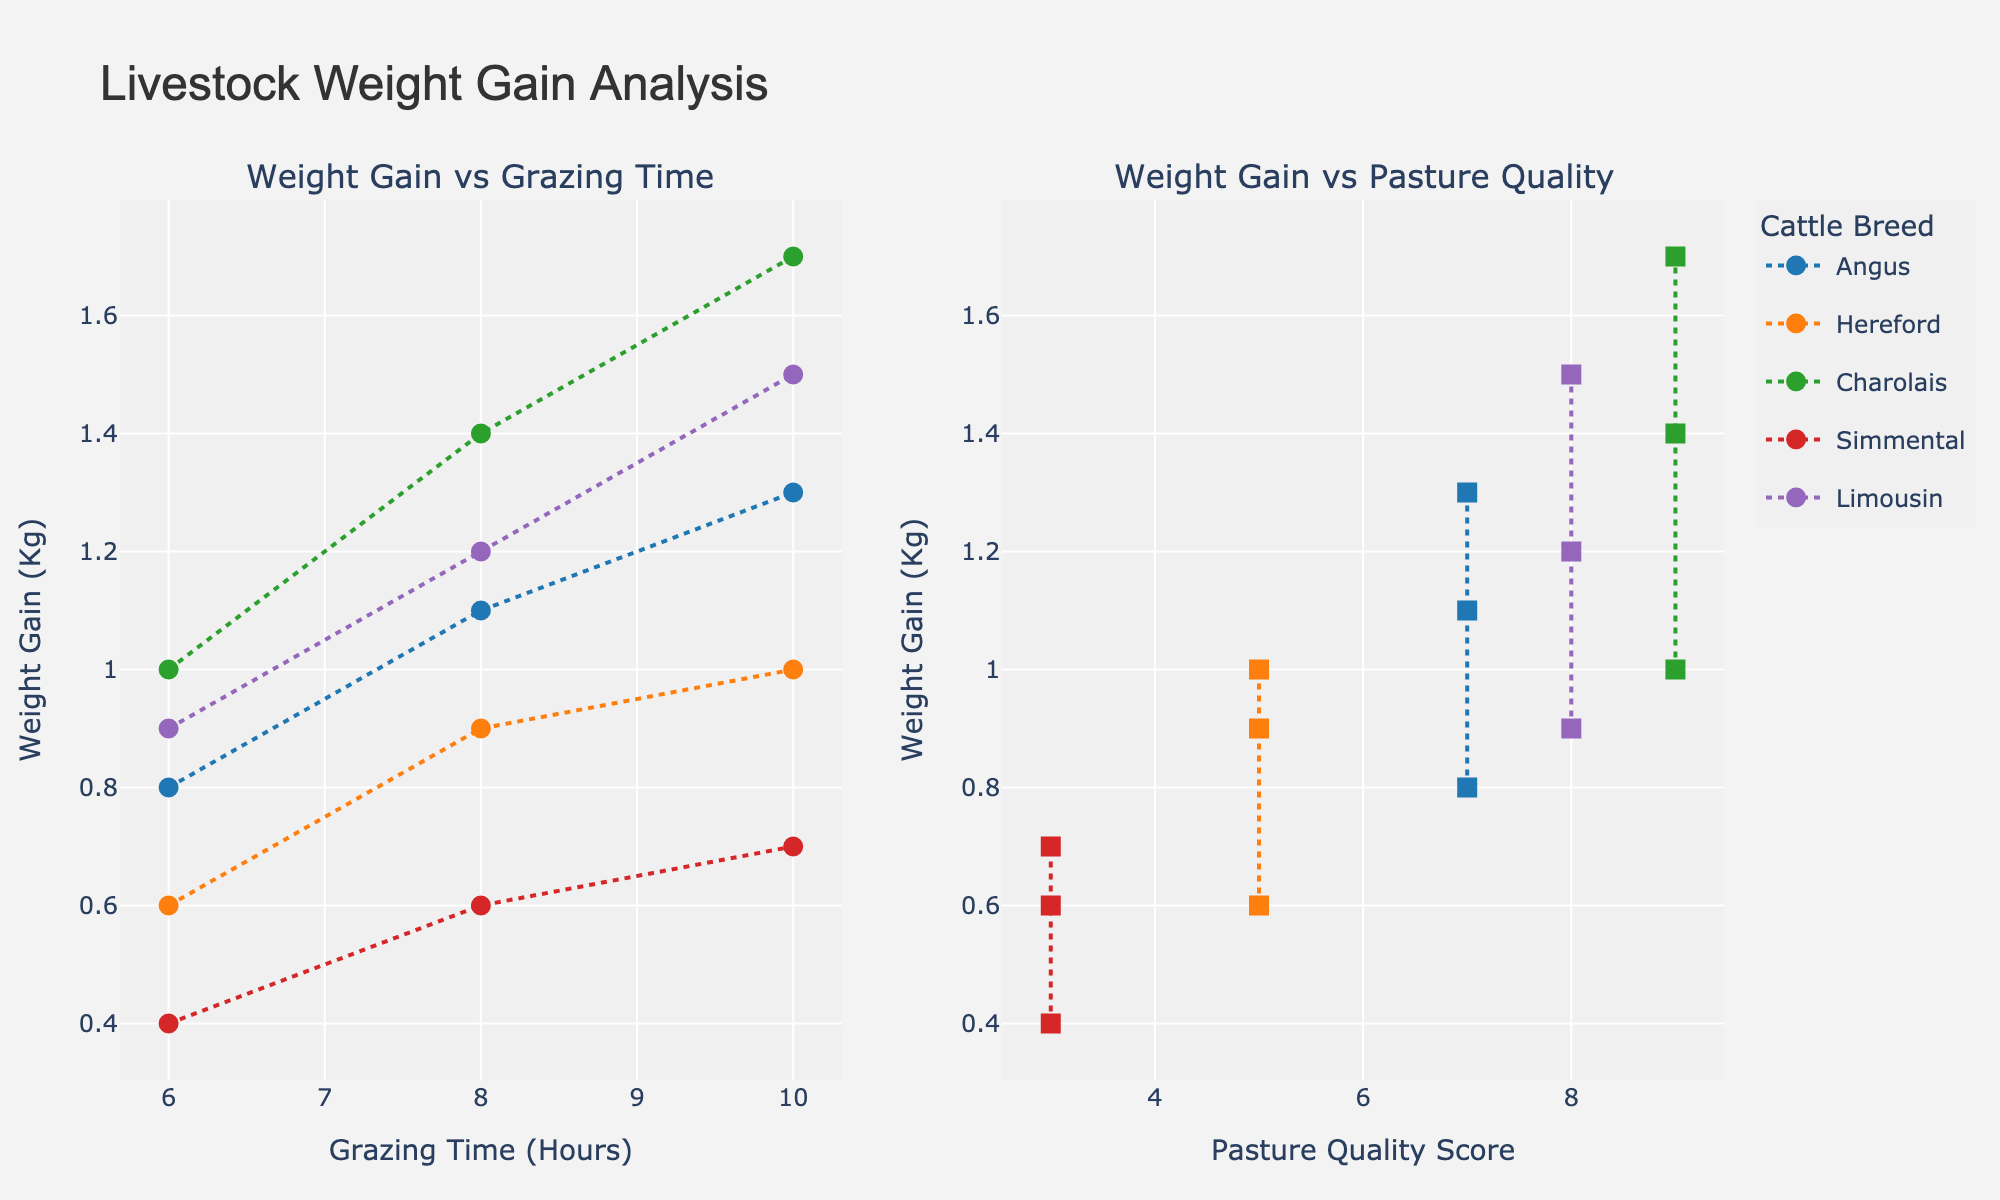Which country has the highest carbon emissions? By looking at the plot for "Carbon Emissions (MtCO2)", identify the point that is at the highest value on the y-axis. The country with the highest value is China at 9877 MtCO2.
Answer: China Which country has the highest renewable energy percentage? Find the plot for "Renewable Energy (%)", and locate the point that is highest on the y-axis. Canada has the highest renewable energy percentage at 67.2%.
Answer: Canada Which country has the worst air quality index? Check the plot for "Air Quality Index" and look for the point with the highest value on the y-axis. India has the highest Air Quality Index at 115.
Answer: India Is there a correlation between high carbon emissions and air quality index? Examine the scatterplot between "Carbon Emissions (MtCO2)" and "Air Quality Index". Look for a trend as to whether high carbon emissions tend to correspond with a high air quality index. Countries like China and India with high emissions also have high air quality index values, suggesting a positive correlation.
Answer: Yes, there appears to be a positive correlation Which country has both low carbon emissions and good air quality? Locate the countries in the plots for "Carbon Emissions (MtCO2)" and "Air Quality Index" that have low values on both axes. France, with 277 MtCO2 and an air quality index of 38, fits this criterion.
Answer: France Compare the renewable energy percentages of Germany and Spain. Which country has a higher percentage? Look at the scatter plot for "Renewable Energy (%)" and identify the points for Germany and Spain. Germany has a renewable energy percentage of 46.3%, whereas Spain has 42.8%. Thus, Germany has a higher percentage.
Answer: Germany How does Canada’s air quality compare to Brazil’s? Compare the points for Canada and Brazil in the "Air Quality Index" plot. Canada's air quality index is 28 while Brazil's is 51, indicating that Canada has better air quality.
Answer: Canada has better air quality Is there an outlier in the "Renewable Energy (%)" among these countries? Check the distribution in the scatter plot for "Renewable Energy (%)" to identify any point that stands out significantly from others. Saudi Arabia, with only 0.3% renewable energy, is a notable outlier.
Answer: Saudi Arabia What is the relationship between renewable energy percentage and air quality index? Observe the scatter plot matrix and especially the scatter plot between "Renewable Energy (%)" and "Air Quality Index". The presence of a clear pattern or trend indicates the relationship. Generally, countries with higher renewable energy percentages tend to have better air quality indexes, suggesting a negative correlation.
Answer: Negative correlation Which country has the closest values of carbon emissions and renewable energy percentage to that of South Korea? Look for the points that are close to the same values of "Carbon Emissions (MtCO2)" and "Renewable Energy (%)" as South Korea in the respective scatter plots. Japan, with carbon emissions of 1106 MtCO2 and a renewable energy percentage of 18.5%, has similar values to South Korea’s 611 MtCO2 and 6.4%.
Answer: Japan 